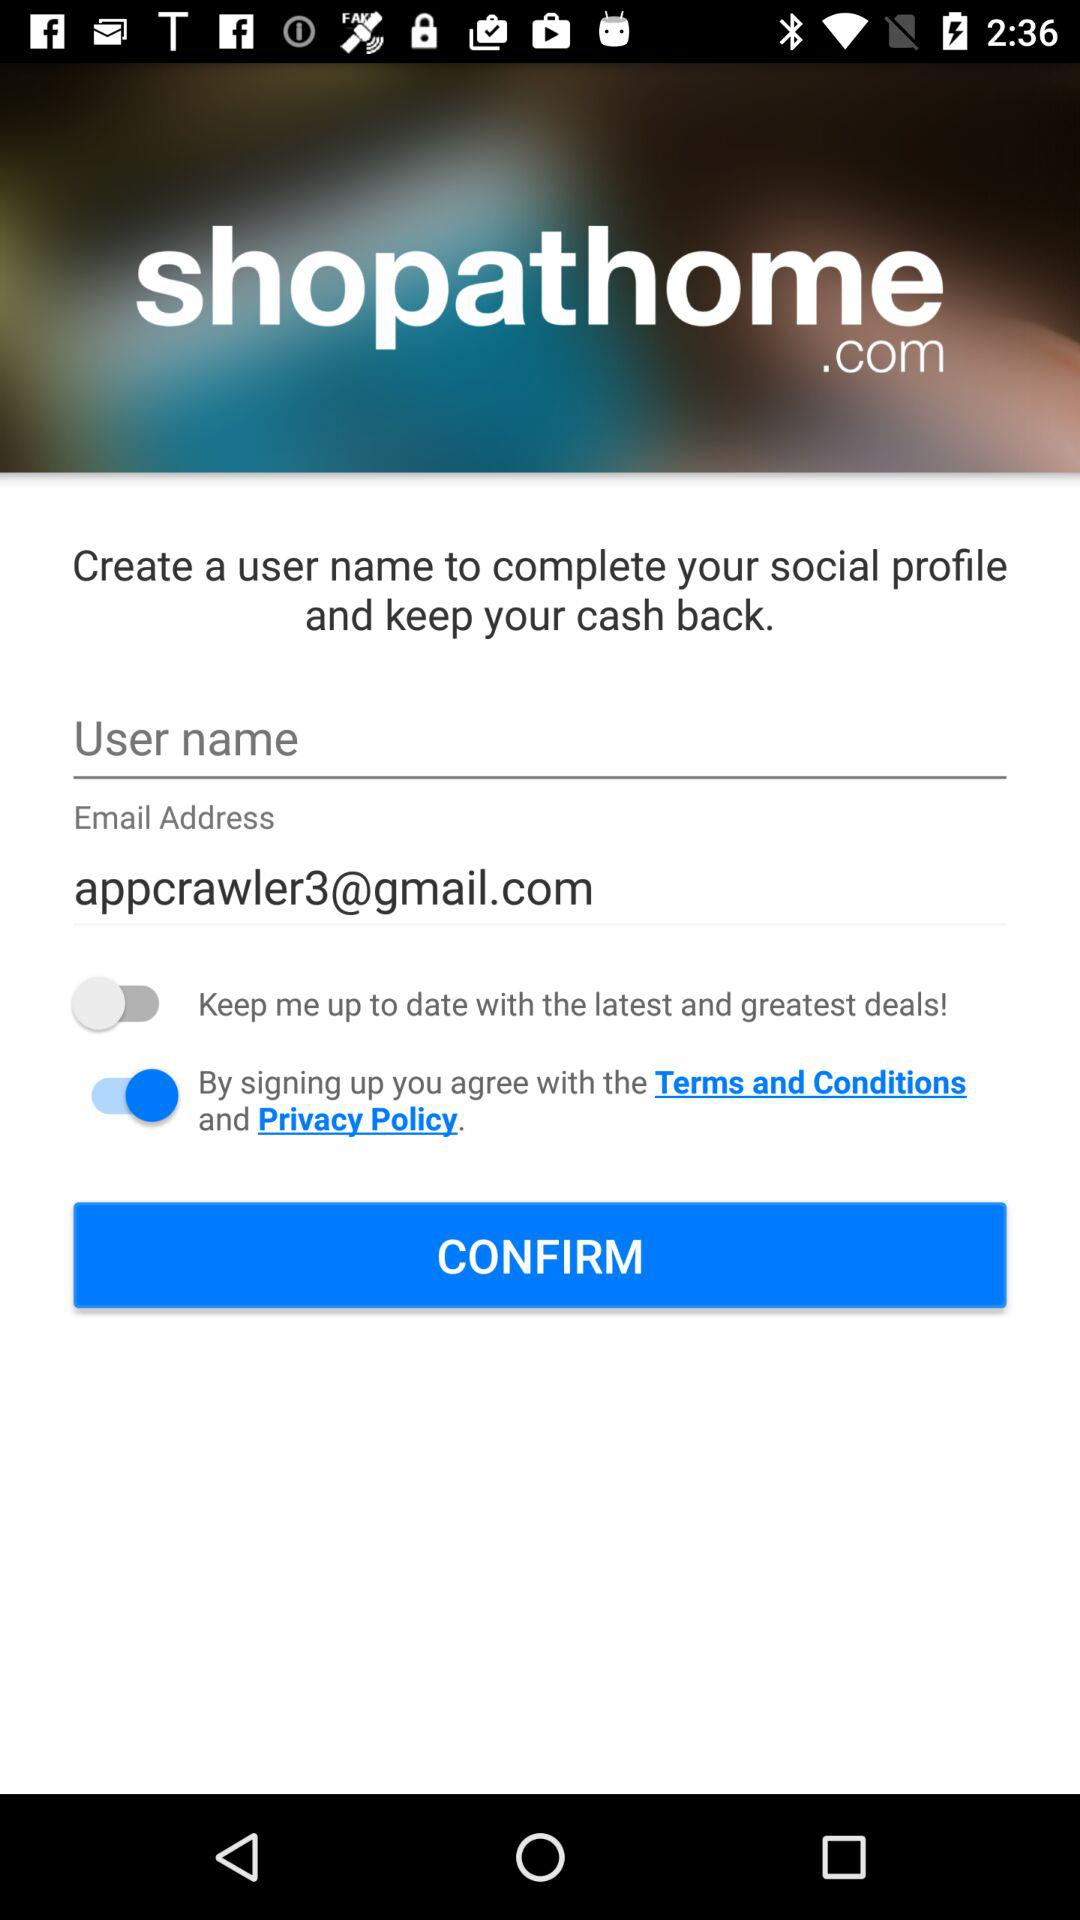What is the email address? The email address is appcrawler3@gmail.com. 